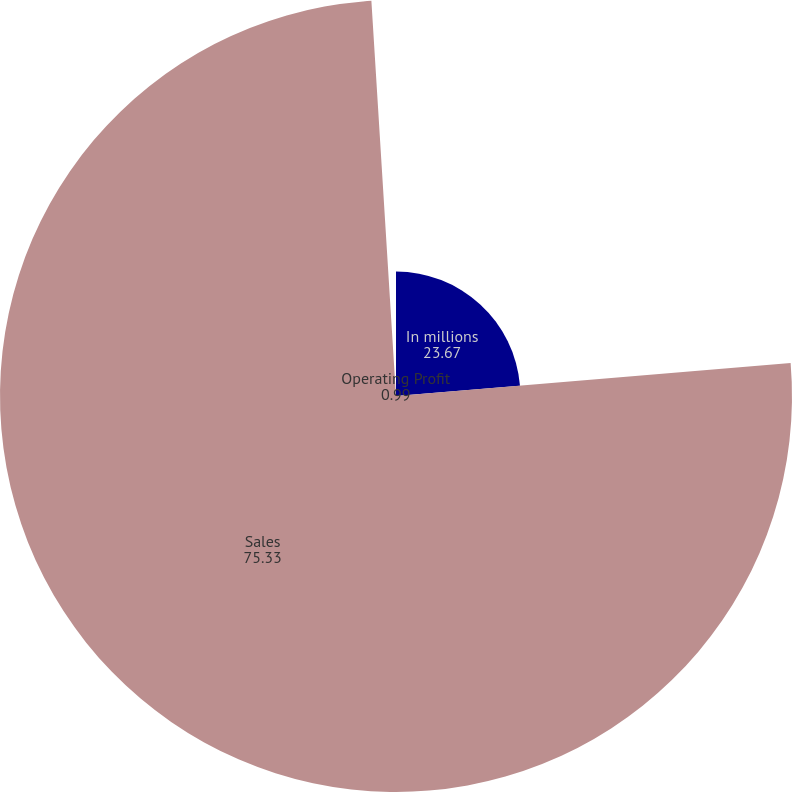Convert chart to OTSL. <chart><loc_0><loc_0><loc_500><loc_500><pie_chart><fcel>In millions<fcel>Sales<fcel>Operating Profit<nl><fcel>23.67%<fcel>75.33%<fcel>0.99%<nl></chart> 